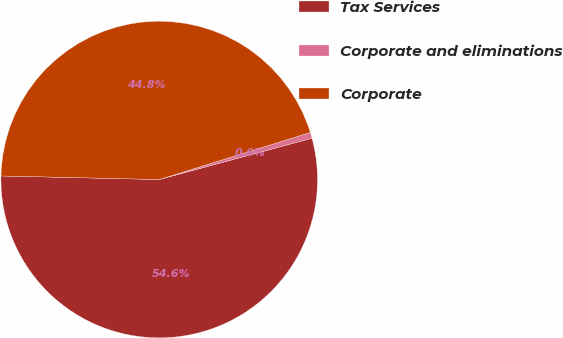<chart> <loc_0><loc_0><loc_500><loc_500><pie_chart><fcel>Tax Services<fcel>Corporate and eliminations<fcel>Corporate<nl><fcel>54.57%<fcel>0.6%<fcel>44.83%<nl></chart> 